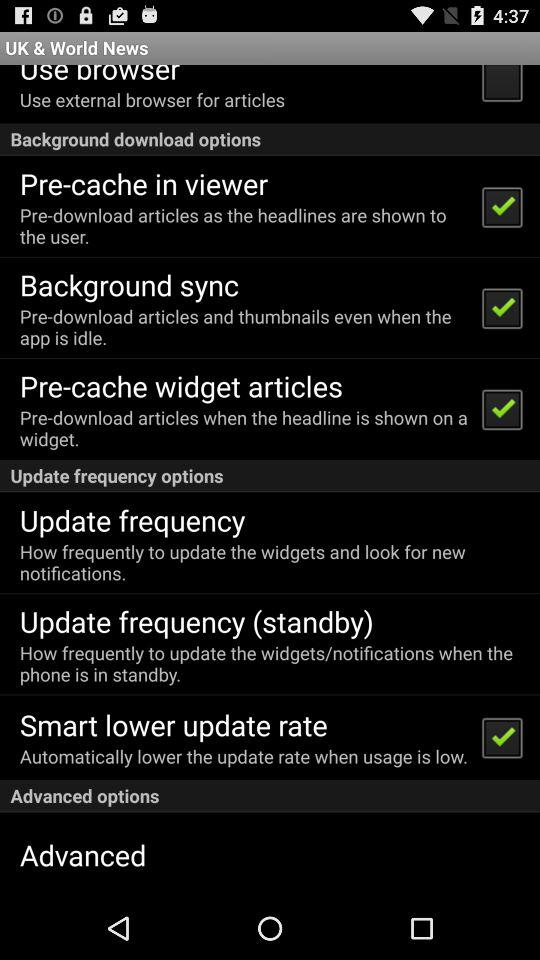What is the current status of the "Background sync"? The current status is "on". 